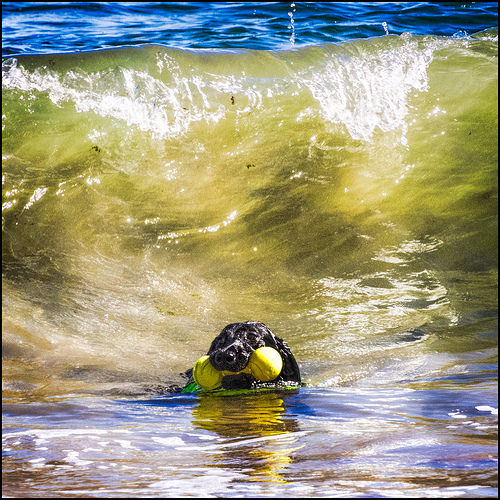<image>
Is the dog in the water? Yes. The dog is contained within or inside the water, showing a containment relationship. 